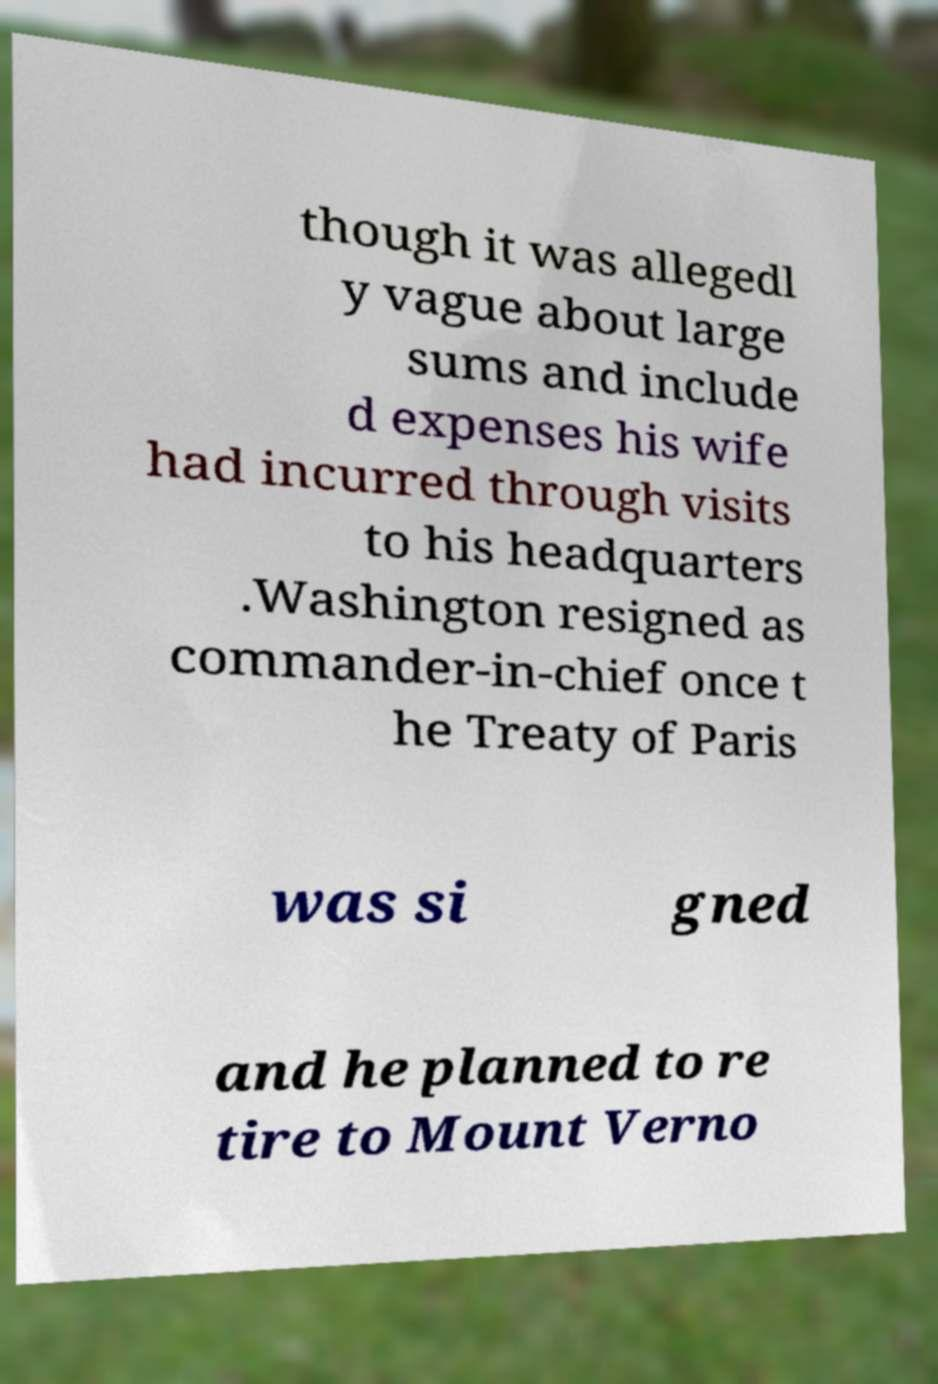For documentation purposes, I need the text within this image transcribed. Could you provide that? though it was allegedl y vague about large sums and include d expenses his wife had incurred through visits to his headquarters .Washington resigned as commander-in-chief once t he Treaty of Paris was si gned and he planned to re tire to Mount Verno 